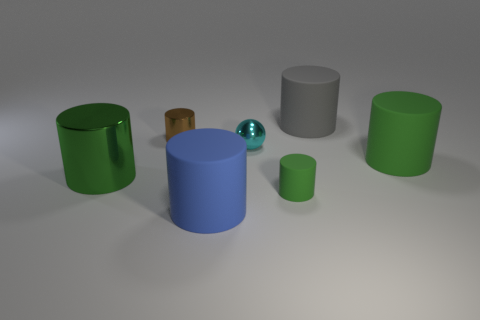Subtract all red balls. How many green cylinders are left? 3 Subtract all gray cylinders. How many cylinders are left? 5 Subtract all small metallic cylinders. How many cylinders are left? 5 Subtract all purple spheres. Subtract all blue cylinders. How many spheres are left? 1 Add 2 small brown cylinders. How many objects exist? 9 Subtract all cylinders. How many objects are left? 1 Add 7 big shiny cylinders. How many big shiny cylinders are left? 8 Add 5 blue rubber objects. How many blue rubber objects exist? 6 Subtract 0 blue spheres. How many objects are left? 7 Subtract all tiny cylinders. Subtract all big cylinders. How many objects are left? 1 